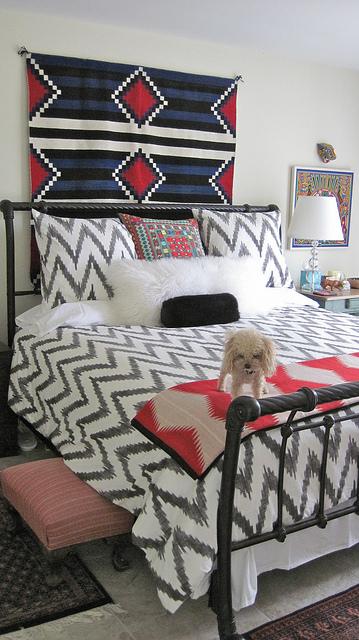What kind of cloth is the poodle standing on?
Write a very short answer. Blanket. How many pillows are on the bed?
Quick response, please. 5. What animal is on the bed?
Concise answer only. Dog. Is there a footstool for the bed?
Concise answer only. Yes. 